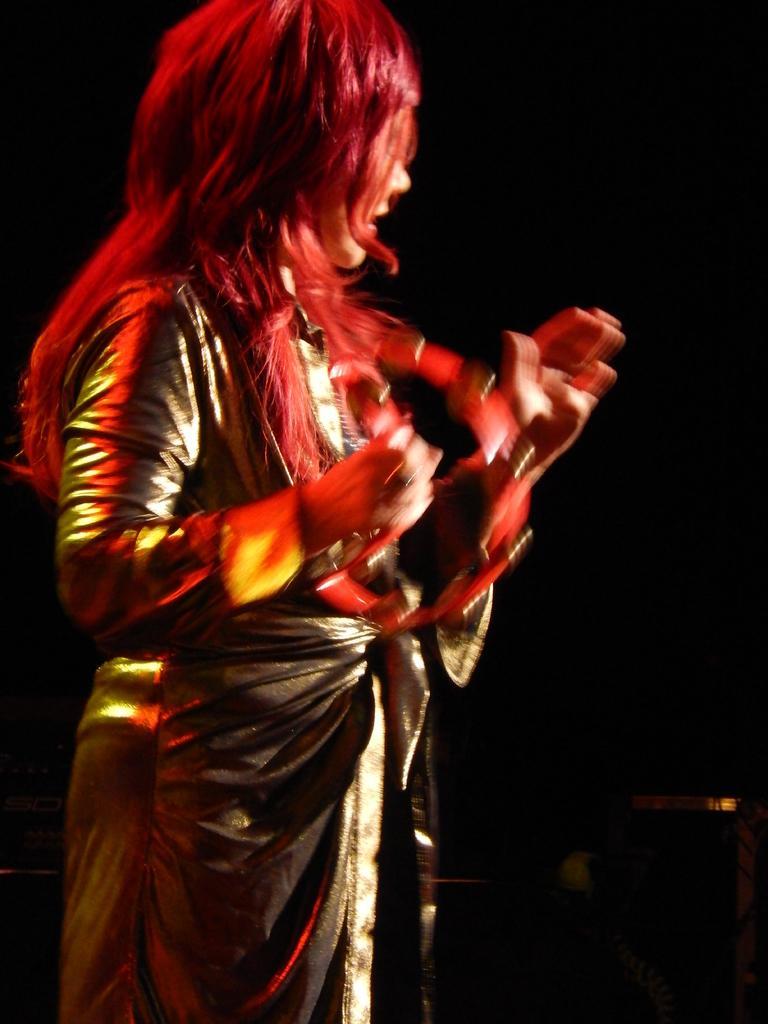Describe this image in one or two sentences. In this image I can see a person standing. There is a black background. 